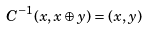Convert formula to latex. <formula><loc_0><loc_0><loc_500><loc_500>C ^ { - 1 } ( x , x \oplus y ) = ( x , y )</formula> 